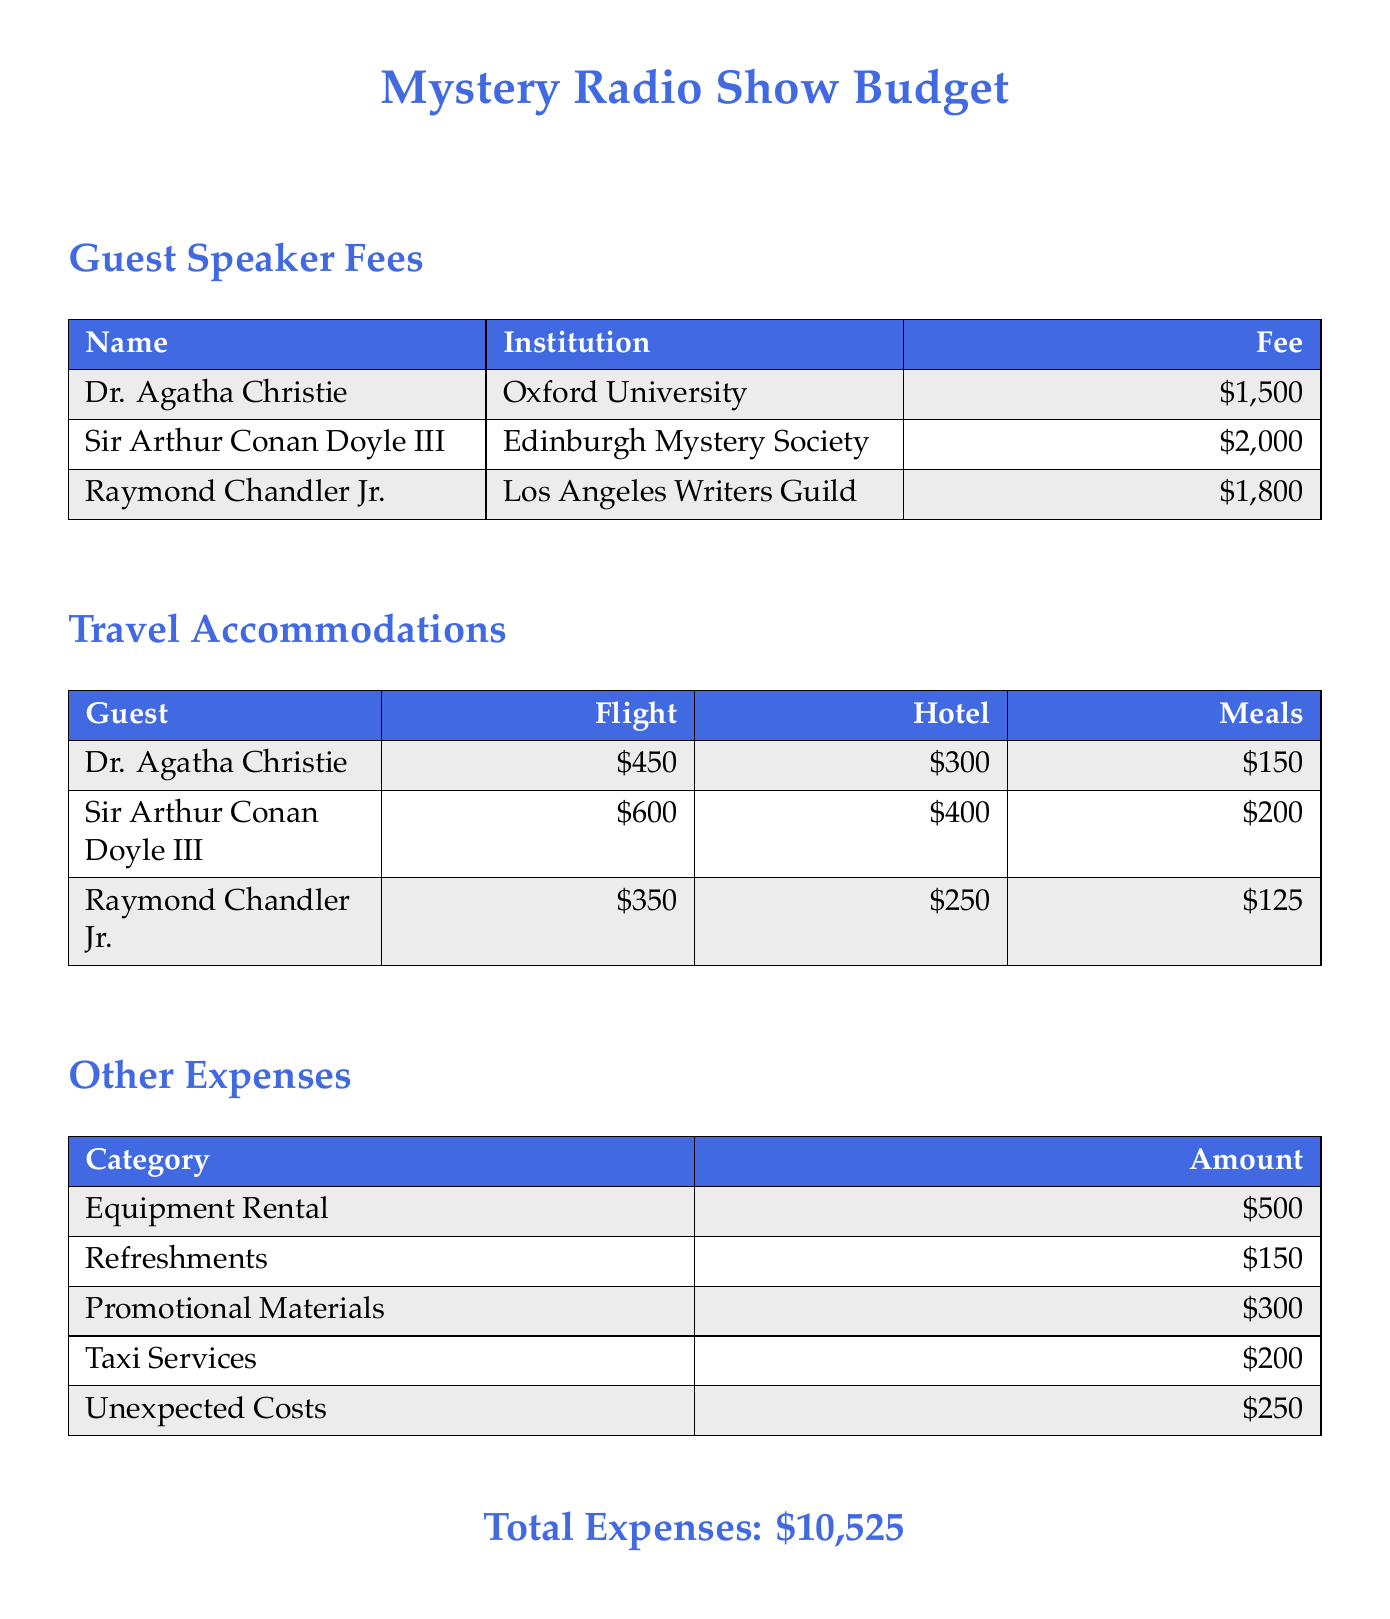What is the total expense? The total expense is clearly stated in the document, which summarizes all costs.
Answer: $10,525 Who is the guest from Oxford University? The document lists Dr. Agatha Christie as the guest from Oxford University.
Answer: Dr. Agatha Christie What is the fee for Sir Arthur Conan Doyle III? The document specifies Sir Arthur Conan Doyle III's fee under guest speaker fees.
Answer: $2,000 How much is allocated for meals for Raymond Chandler Jr.? The meals for Raymond Chandler Jr. are detailed in the travel accommodations section of the document.
Answer: $125 What is the total amount for promotional materials? The document provides a specific amount for promotional materials under other expenses.
Answer: $300 Which guest has the lowest flight cost? The flight costs for each guest are compared to determine the lowest.
Answer: $350 Which institution is Sir Arthur Conan Doyle III affiliated with? The document states the institution associated with Sir Arthur Conan Doyle III.
Answer: Edinburgh Mystery Society What is the budgeted amount for taxi services? The budget includes various other expenses, including taxi services.
Answer: $200 Which category has the highest expense in other expenses? The values in the table help identify the category with the highest expense.
Answer: Equipment Rental 